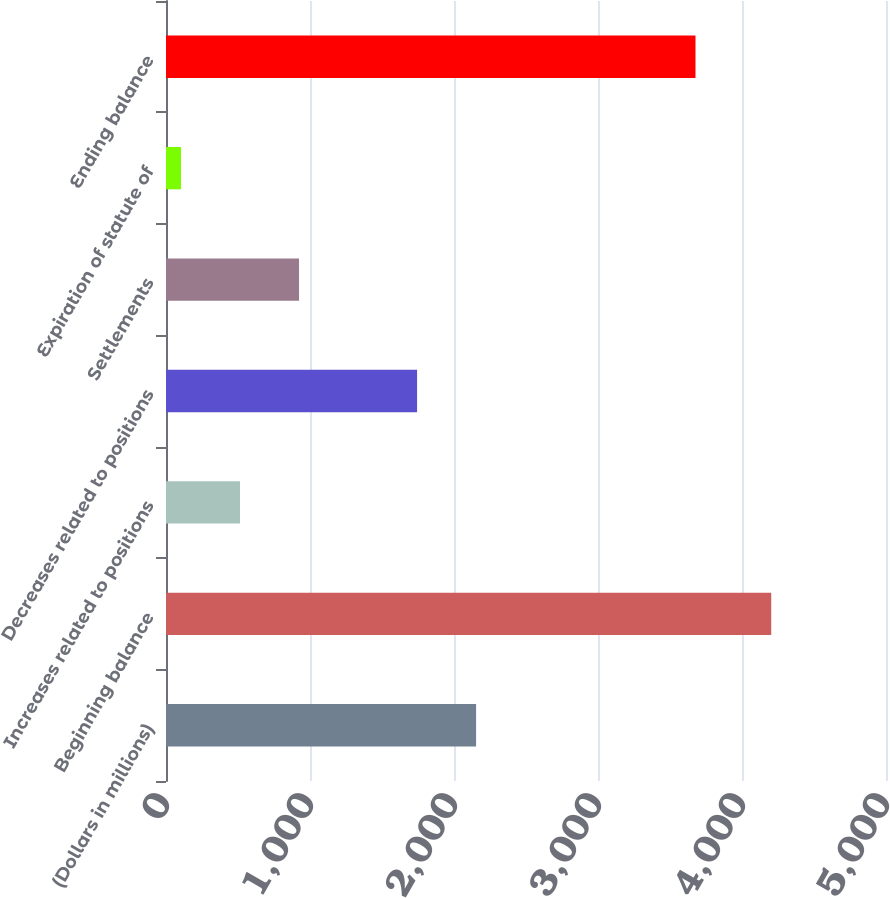<chart> <loc_0><loc_0><loc_500><loc_500><bar_chart><fcel>(Dollars in millions)<fcel>Beginning balance<fcel>Increases related to positions<fcel>Decreases related to positions<fcel>Settlements<fcel>Expiration of statute of<fcel>Ending balance<nl><fcel>2153.5<fcel>4203<fcel>513.9<fcel>1743.6<fcel>923.8<fcel>104<fcel>3677<nl></chart> 